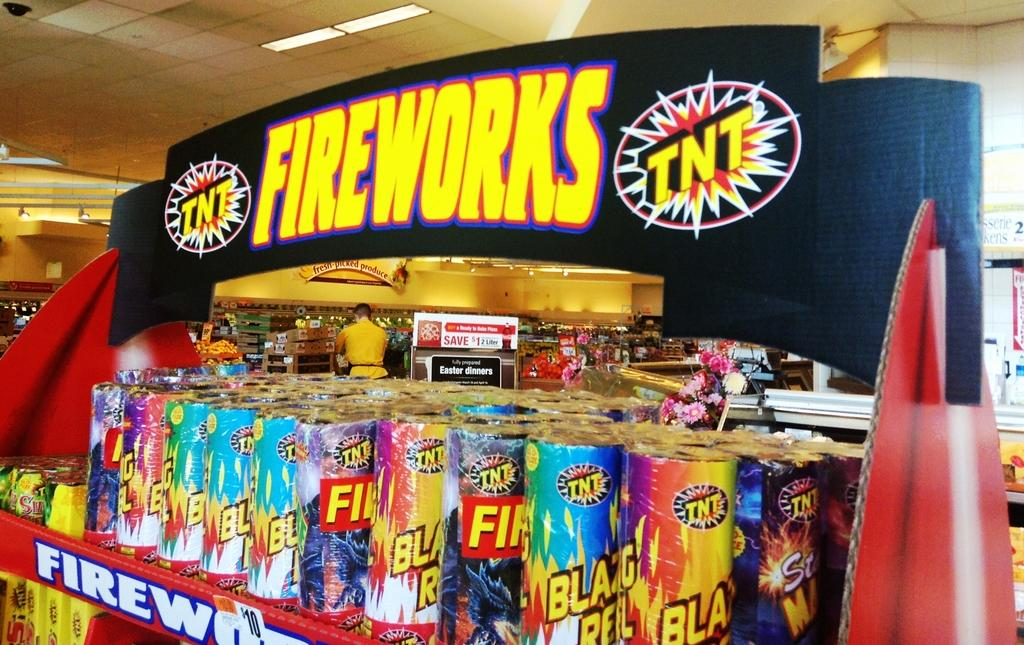Provide a one-sentence caption for the provided image. A colorful display of TNT fireworks for sale. 